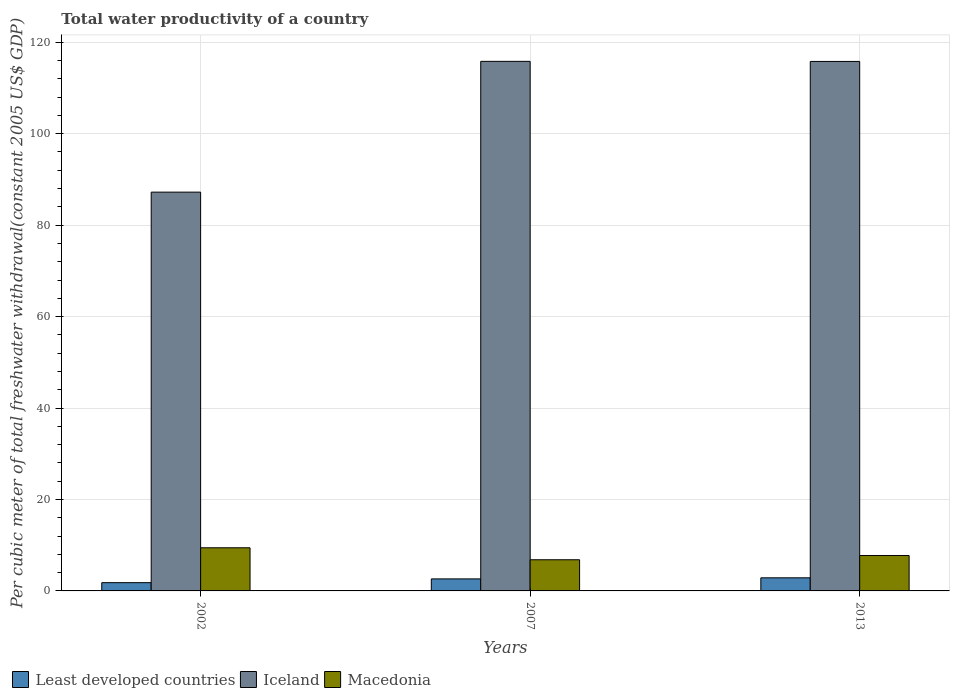How many groups of bars are there?
Provide a succinct answer. 3. Are the number of bars per tick equal to the number of legend labels?
Provide a short and direct response. Yes. What is the label of the 1st group of bars from the left?
Offer a very short reply. 2002. What is the total water productivity in Iceland in 2007?
Ensure brevity in your answer.  115.82. Across all years, what is the maximum total water productivity in Least developed countries?
Your answer should be very brief. 2.86. Across all years, what is the minimum total water productivity in Least developed countries?
Ensure brevity in your answer.  1.81. In which year was the total water productivity in Least developed countries maximum?
Offer a very short reply. 2013. In which year was the total water productivity in Iceland minimum?
Your response must be concise. 2002. What is the total total water productivity in Least developed countries in the graph?
Give a very brief answer. 7.3. What is the difference between the total water productivity in Iceland in 2002 and that in 2013?
Provide a short and direct response. -28.59. What is the difference between the total water productivity in Macedonia in 2007 and the total water productivity in Least developed countries in 2013?
Your answer should be very brief. 3.95. What is the average total water productivity in Macedonia per year?
Ensure brevity in your answer.  8. In the year 2002, what is the difference between the total water productivity in Least developed countries and total water productivity in Iceland?
Your answer should be very brief. -85.41. What is the ratio of the total water productivity in Macedonia in 2007 to that in 2013?
Provide a succinct answer. 0.88. What is the difference between the highest and the second highest total water productivity in Iceland?
Offer a very short reply. 0.02. What is the difference between the highest and the lowest total water productivity in Macedonia?
Provide a succinct answer. 2.62. In how many years, is the total water productivity in Macedonia greater than the average total water productivity in Macedonia taken over all years?
Make the answer very short. 1. Is the sum of the total water productivity in Macedonia in 2002 and 2013 greater than the maximum total water productivity in Least developed countries across all years?
Your answer should be compact. Yes. What does the 1st bar from the left in 2002 represents?
Give a very brief answer. Least developed countries. What does the 3rd bar from the right in 2013 represents?
Offer a terse response. Least developed countries. How many bars are there?
Ensure brevity in your answer.  9. Are all the bars in the graph horizontal?
Keep it short and to the point. No. How many years are there in the graph?
Give a very brief answer. 3. What is the difference between two consecutive major ticks on the Y-axis?
Offer a terse response. 20. Does the graph contain grids?
Your answer should be compact. Yes. How many legend labels are there?
Make the answer very short. 3. How are the legend labels stacked?
Your response must be concise. Horizontal. What is the title of the graph?
Ensure brevity in your answer.  Total water productivity of a country. What is the label or title of the X-axis?
Provide a succinct answer. Years. What is the label or title of the Y-axis?
Offer a very short reply. Per cubic meter of total freshwater withdrawal(constant 2005 US$ GDP). What is the Per cubic meter of total freshwater withdrawal(constant 2005 US$ GDP) of Least developed countries in 2002?
Your answer should be compact. 1.81. What is the Per cubic meter of total freshwater withdrawal(constant 2005 US$ GDP) in Iceland in 2002?
Ensure brevity in your answer.  87.22. What is the Per cubic meter of total freshwater withdrawal(constant 2005 US$ GDP) of Macedonia in 2002?
Keep it short and to the point. 9.43. What is the Per cubic meter of total freshwater withdrawal(constant 2005 US$ GDP) of Least developed countries in 2007?
Give a very brief answer. 2.63. What is the Per cubic meter of total freshwater withdrawal(constant 2005 US$ GDP) in Iceland in 2007?
Give a very brief answer. 115.82. What is the Per cubic meter of total freshwater withdrawal(constant 2005 US$ GDP) of Macedonia in 2007?
Make the answer very short. 6.82. What is the Per cubic meter of total freshwater withdrawal(constant 2005 US$ GDP) in Least developed countries in 2013?
Offer a terse response. 2.86. What is the Per cubic meter of total freshwater withdrawal(constant 2005 US$ GDP) in Iceland in 2013?
Offer a terse response. 115.81. What is the Per cubic meter of total freshwater withdrawal(constant 2005 US$ GDP) in Macedonia in 2013?
Your response must be concise. 7.74. Across all years, what is the maximum Per cubic meter of total freshwater withdrawal(constant 2005 US$ GDP) in Least developed countries?
Give a very brief answer. 2.86. Across all years, what is the maximum Per cubic meter of total freshwater withdrawal(constant 2005 US$ GDP) of Iceland?
Keep it short and to the point. 115.82. Across all years, what is the maximum Per cubic meter of total freshwater withdrawal(constant 2005 US$ GDP) in Macedonia?
Provide a short and direct response. 9.43. Across all years, what is the minimum Per cubic meter of total freshwater withdrawal(constant 2005 US$ GDP) in Least developed countries?
Your response must be concise. 1.81. Across all years, what is the minimum Per cubic meter of total freshwater withdrawal(constant 2005 US$ GDP) in Iceland?
Make the answer very short. 87.22. Across all years, what is the minimum Per cubic meter of total freshwater withdrawal(constant 2005 US$ GDP) in Macedonia?
Offer a terse response. 6.82. What is the total Per cubic meter of total freshwater withdrawal(constant 2005 US$ GDP) in Least developed countries in the graph?
Provide a succinct answer. 7.3. What is the total Per cubic meter of total freshwater withdrawal(constant 2005 US$ GDP) in Iceland in the graph?
Offer a terse response. 318.85. What is the total Per cubic meter of total freshwater withdrawal(constant 2005 US$ GDP) of Macedonia in the graph?
Ensure brevity in your answer.  23.99. What is the difference between the Per cubic meter of total freshwater withdrawal(constant 2005 US$ GDP) of Least developed countries in 2002 and that in 2007?
Your response must be concise. -0.83. What is the difference between the Per cubic meter of total freshwater withdrawal(constant 2005 US$ GDP) of Iceland in 2002 and that in 2007?
Keep it short and to the point. -28.6. What is the difference between the Per cubic meter of total freshwater withdrawal(constant 2005 US$ GDP) in Macedonia in 2002 and that in 2007?
Provide a succinct answer. 2.62. What is the difference between the Per cubic meter of total freshwater withdrawal(constant 2005 US$ GDP) of Least developed countries in 2002 and that in 2013?
Offer a terse response. -1.06. What is the difference between the Per cubic meter of total freshwater withdrawal(constant 2005 US$ GDP) in Iceland in 2002 and that in 2013?
Provide a short and direct response. -28.59. What is the difference between the Per cubic meter of total freshwater withdrawal(constant 2005 US$ GDP) of Macedonia in 2002 and that in 2013?
Provide a succinct answer. 1.69. What is the difference between the Per cubic meter of total freshwater withdrawal(constant 2005 US$ GDP) in Least developed countries in 2007 and that in 2013?
Provide a short and direct response. -0.23. What is the difference between the Per cubic meter of total freshwater withdrawal(constant 2005 US$ GDP) of Iceland in 2007 and that in 2013?
Offer a terse response. 0.02. What is the difference between the Per cubic meter of total freshwater withdrawal(constant 2005 US$ GDP) in Macedonia in 2007 and that in 2013?
Keep it short and to the point. -0.93. What is the difference between the Per cubic meter of total freshwater withdrawal(constant 2005 US$ GDP) in Least developed countries in 2002 and the Per cubic meter of total freshwater withdrawal(constant 2005 US$ GDP) in Iceland in 2007?
Give a very brief answer. -114.02. What is the difference between the Per cubic meter of total freshwater withdrawal(constant 2005 US$ GDP) in Least developed countries in 2002 and the Per cubic meter of total freshwater withdrawal(constant 2005 US$ GDP) in Macedonia in 2007?
Your answer should be very brief. -5.01. What is the difference between the Per cubic meter of total freshwater withdrawal(constant 2005 US$ GDP) in Iceland in 2002 and the Per cubic meter of total freshwater withdrawal(constant 2005 US$ GDP) in Macedonia in 2007?
Your response must be concise. 80.4. What is the difference between the Per cubic meter of total freshwater withdrawal(constant 2005 US$ GDP) of Least developed countries in 2002 and the Per cubic meter of total freshwater withdrawal(constant 2005 US$ GDP) of Iceland in 2013?
Offer a terse response. -114. What is the difference between the Per cubic meter of total freshwater withdrawal(constant 2005 US$ GDP) in Least developed countries in 2002 and the Per cubic meter of total freshwater withdrawal(constant 2005 US$ GDP) in Macedonia in 2013?
Provide a succinct answer. -5.94. What is the difference between the Per cubic meter of total freshwater withdrawal(constant 2005 US$ GDP) of Iceland in 2002 and the Per cubic meter of total freshwater withdrawal(constant 2005 US$ GDP) of Macedonia in 2013?
Provide a succinct answer. 79.48. What is the difference between the Per cubic meter of total freshwater withdrawal(constant 2005 US$ GDP) in Least developed countries in 2007 and the Per cubic meter of total freshwater withdrawal(constant 2005 US$ GDP) in Iceland in 2013?
Ensure brevity in your answer.  -113.17. What is the difference between the Per cubic meter of total freshwater withdrawal(constant 2005 US$ GDP) in Least developed countries in 2007 and the Per cubic meter of total freshwater withdrawal(constant 2005 US$ GDP) in Macedonia in 2013?
Provide a short and direct response. -5.11. What is the difference between the Per cubic meter of total freshwater withdrawal(constant 2005 US$ GDP) of Iceland in 2007 and the Per cubic meter of total freshwater withdrawal(constant 2005 US$ GDP) of Macedonia in 2013?
Your answer should be very brief. 108.08. What is the average Per cubic meter of total freshwater withdrawal(constant 2005 US$ GDP) in Least developed countries per year?
Your answer should be compact. 2.43. What is the average Per cubic meter of total freshwater withdrawal(constant 2005 US$ GDP) of Iceland per year?
Offer a very short reply. 106.28. What is the average Per cubic meter of total freshwater withdrawal(constant 2005 US$ GDP) in Macedonia per year?
Your response must be concise. 8. In the year 2002, what is the difference between the Per cubic meter of total freshwater withdrawal(constant 2005 US$ GDP) in Least developed countries and Per cubic meter of total freshwater withdrawal(constant 2005 US$ GDP) in Iceland?
Make the answer very short. -85.41. In the year 2002, what is the difference between the Per cubic meter of total freshwater withdrawal(constant 2005 US$ GDP) of Least developed countries and Per cubic meter of total freshwater withdrawal(constant 2005 US$ GDP) of Macedonia?
Ensure brevity in your answer.  -7.63. In the year 2002, what is the difference between the Per cubic meter of total freshwater withdrawal(constant 2005 US$ GDP) in Iceland and Per cubic meter of total freshwater withdrawal(constant 2005 US$ GDP) in Macedonia?
Make the answer very short. 77.78. In the year 2007, what is the difference between the Per cubic meter of total freshwater withdrawal(constant 2005 US$ GDP) of Least developed countries and Per cubic meter of total freshwater withdrawal(constant 2005 US$ GDP) of Iceland?
Provide a succinct answer. -113.19. In the year 2007, what is the difference between the Per cubic meter of total freshwater withdrawal(constant 2005 US$ GDP) in Least developed countries and Per cubic meter of total freshwater withdrawal(constant 2005 US$ GDP) in Macedonia?
Your response must be concise. -4.18. In the year 2007, what is the difference between the Per cubic meter of total freshwater withdrawal(constant 2005 US$ GDP) in Iceland and Per cubic meter of total freshwater withdrawal(constant 2005 US$ GDP) in Macedonia?
Your response must be concise. 109.01. In the year 2013, what is the difference between the Per cubic meter of total freshwater withdrawal(constant 2005 US$ GDP) in Least developed countries and Per cubic meter of total freshwater withdrawal(constant 2005 US$ GDP) in Iceland?
Provide a short and direct response. -112.94. In the year 2013, what is the difference between the Per cubic meter of total freshwater withdrawal(constant 2005 US$ GDP) in Least developed countries and Per cubic meter of total freshwater withdrawal(constant 2005 US$ GDP) in Macedonia?
Provide a short and direct response. -4.88. In the year 2013, what is the difference between the Per cubic meter of total freshwater withdrawal(constant 2005 US$ GDP) of Iceland and Per cubic meter of total freshwater withdrawal(constant 2005 US$ GDP) of Macedonia?
Ensure brevity in your answer.  108.06. What is the ratio of the Per cubic meter of total freshwater withdrawal(constant 2005 US$ GDP) of Least developed countries in 2002 to that in 2007?
Your answer should be compact. 0.69. What is the ratio of the Per cubic meter of total freshwater withdrawal(constant 2005 US$ GDP) of Iceland in 2002 to that in 2007?
Keep it short and to the point. 0.75. What is the ratio of the Per cubic meter of total freshwater withdrawal(constant 2005 US$ GDP) of Macedonia in 2002 to that in 2007?
Provide a short and direct response. 1.38. What is the ratio of the Per cubic meter of total freshwater withdrawal(constant 2005 US$ GDP) in Least developed countries in 2002 to that in 2013?
Your answer should be very brief. 0.63. What is the ratio of the Per cubic meter of total freshwater withdrawal(constant 2005 US$ GDP) of Iceland in 2002 to that in 2013?
Ensure brevity in your answer.  0.75. What is the ratio of the Per cubic meter of total freshwater withdrawal(constant 2005 US$ GDP) of Macedonia in 2002 to that in 2013?
Offer a very short reply. 1.22. What is the ratio of the Per cubic meter of total freshwater withdrawal(constant 2005 US$ GDP) in Least developed countries in 2007 to that in 2013?
Give a very brief answer. 0.92. What is the ratio of the Per cubic meter of total freshwater withdrawal(constant 2005 US$ GDP) of Iceland in 2007 to that in 2013?
Provide a short and direct response. 1. What is the ratio of the Per cubic meter of total freshwater withdrawal(constant 2005 US$ GDP) of Macedonia in 2007 to that in 2013?
Provide a short and direct response. 0.88. What is the difference between the highest and the second highest Per cubic meter of total freshwater withdrawal(constant 2005 US$ GDP) in Least developed countries?
Provide a short and direct response. 0.23. What is the difference between the highest and the second highest Per cubic meter of total freshwater withdrawal(constant 2005 US$ GDP) of Iceland?
Keep it short and to the point. 0.02. What is the difference between the highest and the second highest Per cubic meter of total freshwater withdrawal(constant 2005 US$ GDP) in Macedonia?
Give a very brief answer. 1.69. What is the difference between the highest and the lowest Per cubic meter of total freshwater withdrawal(constant 2005 US$ GDP) in Least developed countries?
Ensure brevity in your answer.  1.06. What is the difference between the highest and the lowest Per cubic meter of total freshwater withdrawal(constant 2005 US$ GDP) of Iceland?
Ensure brevity in your answer.  28.6. What is the difference between the highest and the lowest Per cubic meter of total freshwater withdrawal(constant 2005 US$ GDP) in Macedonia?
Your response must be concise. 2.62. 